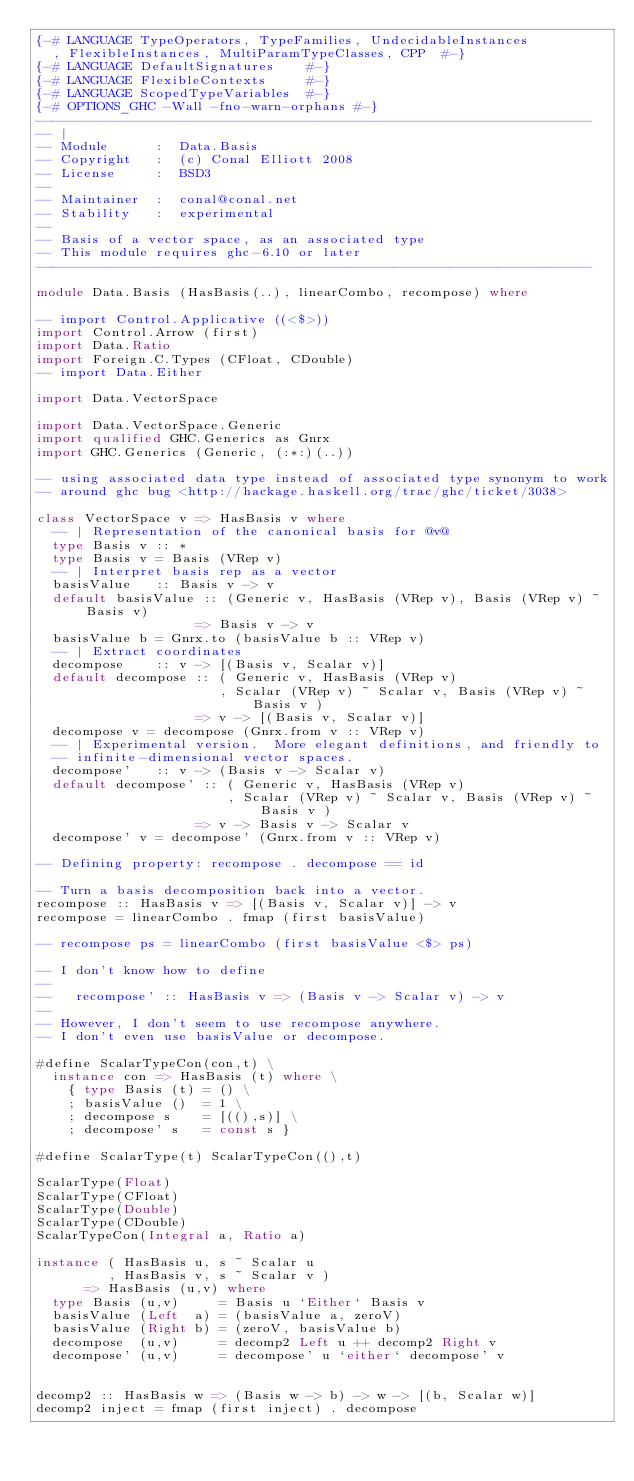<code> <loc_0><loc_0><loc_500><loc_500><_Haskell_>{-# LANGUAGE TypeOperators, TypeFamilies, UndecidableInstances
  , FlexibleInstances, MultiParamTypeClasses, CPP  #-}
{-# LANGUAGE DefaultSignatures    #-}
{-# LANGUAGE FlexibleContexts     #-}
{-# LANGUAGE ScopedTypeVariables  #-}
{-# OPTIONS_GHC -Wall -fno-warn-orphans #-}
----------------------------------------------------------------------
-- |
-- Module      :  Data.Basis
-- Copyright   :  (c) Conal Elliott 2008
-- License     :  BSD3
-- 
-- Maintainer  :  conal@conal.net
-- Stability   :  experimental
-- 
-- Basis of a vector space, as an associated type
-- This module requires ghc-6.10 or later
----------------------------------------------------------------------

module Data.Basis (HasBasis(..), linearCombo, recompose) where

-- import Control.Applicative ((<$>))
import Control.Arrow (first)
import Data.Ratio
import Foreign.C.Types (CFloat, CDouble)
-- import Data.Either

import Data.VectorSpace

import Data.VectorSpace.Generic
import qualified GHC.Generics as Gnrx
import GHC.Generics (Generic, (:*:)(..))

-- using associated data type instead of associated type synonym to work
-- around ghc bug <http://hackage.haskell.org/trac/ghc/ticket/3038>

class VectorSpace v => HasBasis v where
  -- | Representation of the canonical basis for @v@
  type Basis v :: *
  type Basis v = Basis (VRep v)
  -- | Interpret basis rep as a vector
  basisValue   :: Basis v -> v
  default basisValue :: (Generic v, HasBasis (VRep v), Basis (VRep v) ~ Basis v)
                    => Basis v -> v
  basisValue b = Gnrx.to (basisValue b :: VRep v)
  -- | Extract coordinates
  decompose    :: v -> [(Basis v, Scalar v)]
  default decompose :: ( Generic v, HasBasis (VRep v)
                       , Scalar (VRep v) ~ Scalar v, Basis (VRep v) ~ Basis v )
                    => v -> [(Basis v, Scalar v)]
  decompose v = decompose (Gnrx.from v :: VRep v)
  -- | Experimental version.  More elegant definitions, and friendly to
  -- infinite-dimensional vector spaces.
  decompose'   :: v -> (Basis v -> Scalar v)
  default decompose' :: ( Generic v, HasBasis (VRep v)
                        , Scalar (VRep v) ~ Scalar v, Basis (VRep v) ~ Basis v )
                    => v -> Basis v -> Scalar v
  decompose' v = decompose' (Gnrx.from v :: VRep v)

-- Defining property: recompose . decompose == id

-- Turn a basis decomposition back into a vector.
recompose :: HasBasis v => [(Basis v, Scalar v)] -> v
recompose = linearCombo . fmap (first basisValue)

-- recompose ps = linearCombo (first basisValue <$> ps)

-- I don't know how to define
-- 
--   recompose' :: HasBasis v => (Basis v -> Scalar v) -> v
-- 
-- However, I don't seem to use recompose anywhere.
-- I don't even use basisValue or decompose.

#define ScalarTypeCon(con,t) \
  instance con => HasBasis (t) where \
    { type Basis (t) = () \
    ; basisValue ()  = 1 \
    ; decompose s    = [((),s)] \
    ; decompose' s   = const s }

#define ScalarType(t) ScalarTypeCon((),t)

ScalarType(Float)
ScalarType(CFloat)
ScalarType(Double)
ScalarType(CDouble)
ScalarTypeCon(Integral a, Ratio a)

instance ( HasBasis u, s ~ Scalar u
         , HasBasis v, s ~ Scalar v )
      => HasBasis (u,v) where
  type Basis (u,v)     = Basis u `Either` Basis v
  basisValue (Left  a) = (basisValue a, zeroV)
  basisValue (Right b) = (zeroV, basisValue b)
  decompose  (u,v)     = decomp2 Left u ++ decomp2 Right v
  decompose' (u,v)     = decompose' u `either` decompose' v


decomp2 :: HasBasis w => (Basis w -> b) -> w -> [(b, Scalar w)]
decomp2 inject = fmap (first inject) . decompose
</code> 